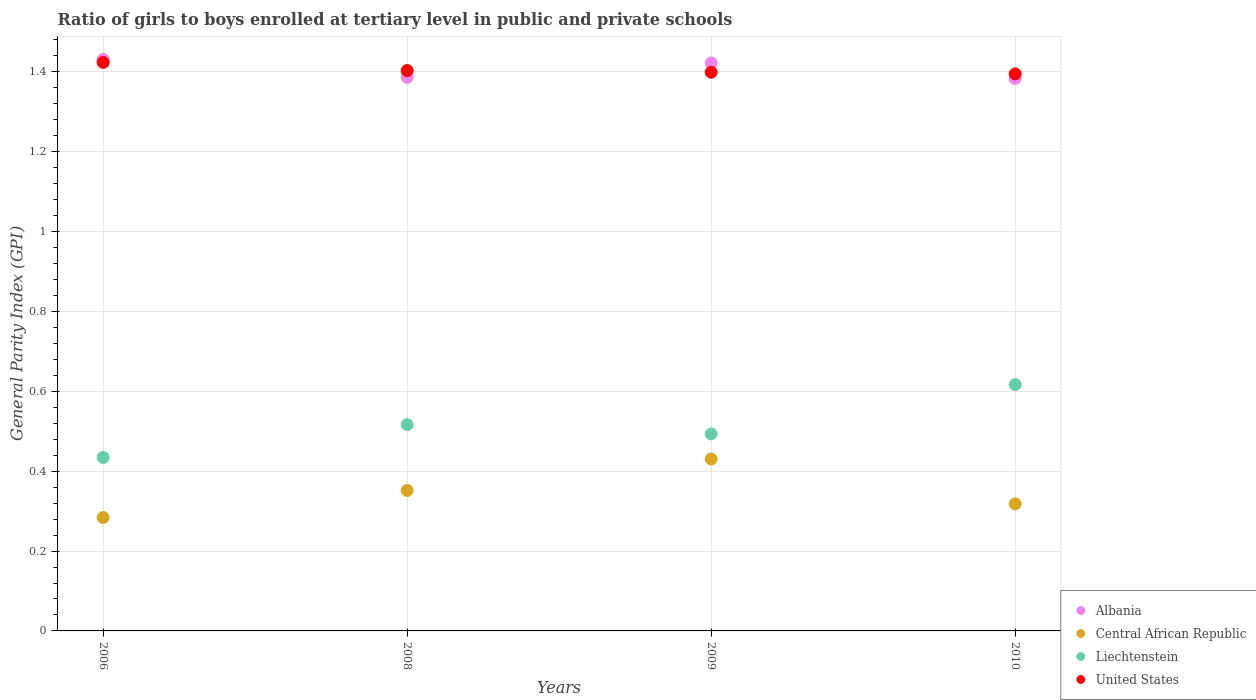What is the general parity index in United States in 2010?
Keep it short and to the point. 1.39. Across all years, what is the maximum general parity index in Liechtenstein?
Provide a succinct answer. 0.62. Across all years, what is the minimum general parity index in United States?
Give a very brief answer. 1.39. In which year was the general parity index in Albania maximum?
Keep it short and to the point. 2006. In which year was the general parity index in United States minimum?
Your answer should be very brief. 2010. What is the total general parity index in United States in the graph?
Offer a very short reply. 5.62. What is the difference between the general parity index in Albania in 2006 and that in 2008?
Your response must be concise. 0.04. What is the difference between the general parity index in Albania in 2008 and the general parity index in United States in 2010?
Give a very brief answer. -0.01. What is the average general parity index in Central African Republic per year?
Provide a succinct answer. 0.35. In the year 2008, what is the difference between the general parity index in Liechtenstein and general parity index in Albania?
Keep it short and to the point. -0.87. What is the ratio of the general parity index in Central African Republic in 2008 to that in 2010?
Offer a very short reply. 1.11. What is the difference between the highest and the second highest general parity index in Central African Republic?
Your answer should be very brief. 0.08. What is the difference between the highest and the lowest general parity index in Central African Republic?
Provide a succinct answer. 0.15. Is the sum of the general parity index in United States in 2006 and 2009 greater than the maximum general parity index in Liechtenstein across all years?
Make the answer very short. Yes. Is it the case that in every year, the sum of the general parity index in United States and general parity index in Central African Republic  is greater than the sum of general parity index in Liechtenstein and general parity index in Albania?
Your response must be concise. No. Are the values on the major ticks of Y-axis written in scientific E-notation?
Provide a succinct answer. No. Where does the legend appear in the graph?
Provide a short and direct response. Bottom right. How many legend labels are there?
Your answer should be very brief. 4. How are the legend labels stacked?
Your answer should be compact. Vertical. What is the title of the graph?
Keep it short and to the point. Ratio of girls to boys enrolled at tertiary level in public and private schools. What is the label or title of the X-axis?
Ensure brevity in your answer.  Years. What is the label or title of the Y-axis?
Your response must be concise. General Parity Index (GPI). What is the General Parity Index (GPI) of Albania in 2006?
Your answer should be compact. 1.43. What is the General Parity Index (GPI) in Central African Republic in 2006?
Your response must be concise. 0.28. What is the General Parity Index (GPI) of Liechtenstein in 2006?
Ensure brevity in your answer.  0.43. What is the General Parity Index (GPI) in United States in 2006?
Ensure brevity in your answer.  1.42. What is the General Parity Index (GPI) in Albania in 2008?
Offer a very short reply. 1.39. What is the General Parity Index (GPI) in Central African Republic in 2008?
Your answer should be compact. 0.35. What is the General Parity Index (GPI) of Liechtenstein in 2008?
Your response must be concise. 0.52. What is the General Parity Index (GPI) in United States in 2008?
Your response must be concise. 1.4. What is the General Parity Index (GPI) in Albania in 2009?
Your response must be concise. 1.42. What is the General Parity Index (GPI) in Central African Republic in 2009?
Offer a terse response. 0.43. What is the General Parity Index (GPI) of Liechtenstein in 2009?
Ensure brevity in your answer.  0.49. What is the General Parity Index (GPI) of United States in 2009?
Your answer should be very brief. 1.4. What is the General Parity Index (GPI) in Albania in 2010?
Ensure brevity in your answer.  1.38. What is the General Parity Index (GPI) of Central African Republic in 2010?
Give a very brief answer. 0.32. What is the General Parity Index (GPI) in Liechtenstein in 2010?
Give a very brief answer. 0.62. What is the General Parity Index (GPI) of United States in 2010?
Give a very brief answer. 1.39. Across all years, what is the maximum General Parity Index (GPI) of Albania?
Ensure brevity in your answer.  1.43. Across all years, what is the maximum General Parity Index (GPI) of Central African Republic?
Make the answer very short. 0.43. Across all years, what is the maximum General Parity Index (GPI) of Liechtenstein?
Make the answer very short. 0.62. Across all years, what is the maximum General Parity Index (GPI) of United States?
Offer a terse response. 1.42. Across all years, what is the minimum General Parity Index (GPI) of Albania?
Give a very brief answer. 1.38. Across all years, what is the minimum General Parity Index (GPI) of Central African Republic?
Your answer should be very brief. 0.28. Across all years, what is the minimum General Parity Index (GPI) in Liechtenstein?
Your answer should be very brief. 0.43. Across all years, what is the minimum General Parity Index (GPI) in United States?
Offer a terse response. 1.39. What is the total General Parity Index (GPI) in Albania in the graph?
Your response must be concise. 5.62. What is the total General Parity Index (GPI) in Central African Republic in the graph?
Your response must be concise. 1.38. What is the total General Parity Index (GPI) of Liechtenstein in the graph?
Offer a very short reply. 2.06. What is the total General Parity Index (GPI) in United States in the graph?
Make the answer very short. 5.62. What is the difference between the General Parity Index (GPI) in Albania in 2006 and that in 2008?
Ensure brevity in your answer.  0.04. What is the difference between the General Parity Index (GPI) in Central African Republic in 2006 and that in 2008?
Provide a succinct answer. -0.07. What is the difference between the General Parity Index (GPI) of Liechtenstein in 2006 and that in 2008?
Make the answer very short. -0.08. What is the difference between the General Parity Index (GPI) in United States in 2006 and that in 2008?
Provide a succinct answer. 0.02. What is the difference between the General Parity Index (GPI) of Albania in 2006 and that in 2009?
Make the answer very short. 0.01. What is the difference between the General Parity Index (GPI) of Central African Republic in 2006 and that in 2009?
Your answer should be very brief. -0.15. What is the difference between the General Parity Index (GPI) of Liechtenstein in 2006 and that in 2009?
Offer a very short reply. -0.06. What is the difference between the General Parity Index (GPI) of United States in 2006 and that in 2009?
Your answer should be very brief. 0.02. What is the difference between the General Parity Index (GPI) in Albania in 2006 and that in 2010?
Your answer should be compact. 0.05. What is the difference between the General Parity Index (GPI) in Central African Republic in 2006 and that in 2010?
Your answer should be very brief. -0.03. What is the difference between the General Parity Index (GPI) in Liechtenstein in 2006 and that in 2010?
Provide a short and direct response. -0.18. What is the difference between the General Parity Index (GPI) of United States in 2006 and that in 2010?
Offer a very short reply. 0.03. What is the difference between the General Parity Index (GPI) in Albania in 2008 and that in 2009?
Provide a short and direct response. -0.04. What is the difference between the General Parity Index (GPI) of Central African Republic in 2008 and that in 2009?
Offer a terse response. -0.08. What is the difference between the General Parity Index (GPI) in Liechtenstein in 2008 and that in 2009?
Your answer should be compact. 0.02. What is the difference between the General Parity Index (GPI) in United States in 2008 and that in 2009?
Give a very brief answer. 0. What is the difference between the General Parity Index (GPI) in Albania in 2008 and that in 2010?
Your answer should be compact. 0. What is the difference between the General Parity Index (GPI) of Central African Republic in 2008 and that in 2010?
Offer a terse response. 0.03. What is the difference between the General Parity Index (GPI) of Liechtenstein in 2008 and that in 2010?
Provide a succinct answer. -0.1. What is the difference between the General Parity Index (GPI) of United States in 2008 and that in 2010?
Your answer should be very brief. 0.01. What is the difference between the General Parity Index (GPI) in Albania in 2009 and that in 2010?
Keep it short and to the point. 0.04. What is the difference between the General Parity Index (GPI) of Central African Republic in 2009 and that in 2010?
Offer a very short reply. 0.11. What is the difference between the General Parity Index (GPI) of Liechtenstein in 2009 and that in 2010?
Provide a short and direct response. -0.12. What is the difference between the General Parity Index (GPI) in United States in 2009 and that in 2010?
Provide a short and direct response. 0. What is the difference between the General Parity Index (GPI) in Albania in 2006 and the General Parity Index (GPI) in Central African Republic in 2008?
Your answer should be compact. 1.08. What is the difference between the General Parity Index (GPI) in Albania in 2006 and the General Parity Index (GPI) in Liechtenstein in 2008?
Offer a very short reply. 0.91. What is the difference between the General Parity Index (GPI) of Albania in 2006 and the General Parity Index (GPI) of United States in 2008?
Your response must be concise. 0.03. What is the difference between the General Parity Index (GPI) in Central African Republic in 2006 and the General Parity Index (GPI) in Liechtenstein in 2008?
Provide a short and direct response. -0.23. What is the difference between the General Parity Index (GPI) of Central African Republic in 2006 and the General Parity Index (GPI) of United States in 2008?
Your answer should be very brief. -1.12. What is the difference between the General Parity Index (GPI) of Liechtenstein in 2006 and the General Parity Index (GPI) of United States in 2008?
Offer a very short reply. -0.97. What is the difference between the General Parity Index (GPI) of Albania in 2006 and the General Parity Index (GPI) of Liechtenstein in 2009?
Offer a terse response. 0.94. What is the difference between the General Parity Index (GPI) in Albania in 2006 and the General Parity Index (GPI) in United States in 2009?
Keep it short and to the point. 0.03. What is the difference between the General Parity Index (GPI) in Central African Republic in 2006 and the General Parity Index (GPI) in Liechtenstein in 2009?
Your answer should be compact. -0.21. What is the difference between the General Parity Index (GPI) of Central African Republic in 2006 and the General Parity Index (GPI) of United States in 2009?
Make the answer very short. -1.12. What is the difference between the General Parity Index (GPI) in Liechtenstein in 2006 and the General Parity Index (GPI) in United States in 2009?
Provide a short and direct response. -0.96. What is the difference between the General Parity Index (GPI) of Albania in 2006 and the General Parity Index (GPI) of Central African Republic in 2010?
Your response must be concise. 1.11. What is the difference between the General Parity Index (GPI) in Albania in 2006 and the General Parity Index (GPI) in Liechtenstein in 2010?
Offer a very short reply. 0.81. What is the difference between the General Parity Index (GPI) of Albania in 2006 and the General Parity Index (GPI) of United States in 2010?
Ensure brevity in your answer.  0.04. What is the difference between the General Parity Index (GPI) of Central African Republic in 2006 and the General Parity Index (GPI) of Liechtenstein in 2010?
Provide a succinct answer. -0.33. What is the difference between the General Parity Index (GPI) in Central African Republic in 2006 and the General Parity Index (GPI) in United States in 2010?
Make the answer very short. -1.11. What is the difference between the General Parity Index (GPI) of Liechtenstein in 2006 and the General Parity Index (GPI) of United States in 2010?
Provide a short and direct response. -0.96. What is the difference between the General Parity Index (GPI) in Albania in 2008 and the General Parity Index (GPI) in Central African Republic in 2009?
Keep it short and to the point. 0.96. What is the difference between the General Parity Index (GPI) of Albania in 2008 and the General Parity Index (GPI) of Liechtenstein in 2009?
Keep it short and to the point. 0.89. What is the difference between the General Parity Index (GPI) in Albania in 2008 and the General Parity Index (GPI) in United States in 2009?
Your response must be concise. -0.01. What is the difference between the General Parity Index (GPI) of Central African Republic in 2008 and the General Parity Index (GPI) of Liechtenstein in 2009?
Give a very brief answer. -0.14. What is the difference between the General Parity Index (GPI) of Central African Republic in 2008 and the General Parity Index (GPI) of United States in 2009?
Your response must be concise. -1.05. What is the difference between the General Parity Index (GPI) in Liechtenstein in 2008 and the General Parity Index (GPI) in United States in 2009?
Ensure brevity in your answer.  -0.88. What is the difference between the General Parity Index (GPI) in Albania in 2008 and the General Parity Index (GPI) in Central African Republic in 2010?
Your response must be concise. 1.07. What is the difference between the General Parity Index (GPI) of Albania in 2008 and the General Parity Index (GPI) of Liechtenstein in 2010?
Your answer should be compact. 0.77. What is the difference between the General Parity Index (GPI) of Albania in 2008 and the General Parity Index (GPI) of United States in 2010?
Your response must be concise. -0.01. What is the difference between the General Parity Index (GPI) in Central African Republic in 2008 and the General Parity Index (GPI) in Liechtenstein in 2010?
Provide a succinct answer. -0.27. What is the difference between the General Parity Index (GPI) in Central African Republic in 2008 and the General Parity Index (GPI) in United States in 2010?
Give a very brief answer. -1.04. What is the difference between the General Parity Index (GPI) in Liechtenstein in 2008 and the General Parity Index (GPI) in United States in 2010?
Give a very brief answer. -0.88. What is the difference between the General Parity Index (GPI) of Albania in 2009 and the General Parity Index (GPI) of Central African Republic in 2010?
Offer a terse response. 1.1. What is the difference between the General Parity Index (GPI) of Albania in 2009 and the General Parity Index (GPI) of Liechtenstein in 2010?
Offer a very short reply. 0.81. What is the difference between the General Parity Index (GPI) of Albania in 2009 and the General Parity Index (GPI) of United States in 2010?
Keep it short and to the point. 0.03. What is the difference between the General Parity Index (GPI) of Central African Republic in 2009 and the General Parity Index (GPI) of Liechtenstein in 2010?
Your answer should be compact. -0.19. What is the difference between the General Parity Index (GPI) of Central African Republic in 2009 and the General Parity Index (GPI) of United States in 2010?
Ensure brevity in your answer.  -0.96. What is the difference between the General Parity Index (GPI) in Liechtenstein in 2009 and the General Parity Index (GPI) in United States in 2010?
Provide a succinct answer. -0.9. What is the average General Parity Index (GPI) in Albania per year?
Provide a short and direct response. 1.41. What is the average General Parity Index (GPI) of Central African Republic per year?
Ensure brevity in your answer.  0.35. What is the average General Parity Index (GPI) in Liechtenstein per year?
Provide a succinct answer. 0.52. What is the average General Parity Index (GPI) in United States per year?
Offer a terse response. 1.41. In the year 2006, what is the difference between the General Parity Index (GPI) of Albania and General Parity Index (GPI) of Central African Republic?
Your answer should be very brief. 1.15. In the year 2006, what is the difference between the General Parity Index (GPI) of Albania and General Parity Index (GPI) of United States?
Offer a very short reply. 0.01. In the year 2006, what is the difference between the General Parity Index (GPI) in Central African Republic and General Parity Index (GPI) in Liechtenstein?
Ensure brevity in your answer.  -0.15. In the year 2006, what is the difference between the General Parity Index (GPI) of Central African Republic and General Parity Index (GPI) of United States?
Your answer should be very brief. -1.14. In the year 2006, what is the difference between the General Parity Index (GPI) in Liechtenstein and General Parity Index (GPI) in United States?
Ensure brevity in your answer.  -0.99. In the year 2008, what is the difference between the General Parity Index (GPI) in Albania and General Parity Index (GPI) in Central African Republic?
Offer a very short reply. 1.03. In the year 2008, what is the difference between the General Parity Index (GPI) of Albania and General Parity Index (GPI) of Liechtenstein?
Your answer should be compact. 0.87. In the year 2008, what is the difference between the General Parity Index (GPI) in Albania and General Parity Index (GPI) in United States?
Ensure brevity in your answer.  -0.02. In the year 2008, what is the difference between the General Parity Index (GPI) of Central African Republic and General Parity Index (GPI) of Liechtenstein?
Your response must be concise. -0.17. In the year 2008, what is the difference between the General Parity Index (GPI) of Central African Republic and General Parity Index (GPI) of United States?
Make the answer very short. -1.05. In the year 2008, what is the difference between the General Parity Index (GPI) of Liechtenstein and General Parity Index (GPI) of United States?
Ensure brevity in your answer.  -0.89. In the year 2009, what is the difference between the General Parity Index (GPI) in Albania and General Parity Index (GPI) in Central African Republic?
Keep it short and to the point. 0.99. In the year 2009, what is the difference between the General Parity Index (GPI) in Albania and General Parity Index (GPI) in Liechtenstein?
Offer a terse response. 0.93. In the year 2009, what is the difference between the General Parity Index (GPI) of Albania and General Parity Index (GPI) of United States?
Your answer should be very brief. 0.02. In the year 2009, what is the difference between the General Parity Index (GPI) of Central African Republic and General Parity Index (GPI) of Liechtenstein?
Give a very brief answer. -0.06. In the year 2009, what is the difference between the General Parity Index (GPI) in Central African Republic and General Parity Index (GPI) in United States?
Provide a succinct answer. -0.97. In the year 2009, what is the difference between the General Parity Index (GPI) of Liechtenstein and General Parity Index (GPI) of United States?
Make the answer very short. -0.91. In the year 2010, what is the difference between the General Parity Index (GPI) in Albania and General Parity Index (GPI) in Central African Republic?
Give a very brief answer. 1.07. In the year 2010, what is the difference between the General Parity Index (GPI) of Albania and General Parity Index (GPI) of Liechtenstein?
Provide a succinct answer. 0.77. In the year 2010, what is the difference between the General Parity Index (GPI) of Albania and General Parity Index (GPI) of United States?
Make the answer very short. -0.01. In the year 2010, what is the difference between the General Parity Index (GPI) of Central African Republic and General Parity Index (GPI) of Liechtenstein?
Keep it short and to the point. -0.3. In the year 2010, what is the difference between the General Parity Index (GPI) of Central African Republic and General Parity Index (GPI) of United States?
Keep it short and to the point. -1.08. In the year 2010, what is the difference between the General Parity Index (GPI) in Liechtenstein and General Parity Index (GPI) in United States?
Your answer should be compact. -0.78. What is the ratio of the General Parity Index (GPI) of Albania in 2006 to that in 2008?
Your answer should be compact. 1.03. What is the ratio of the General Parity Index (GPI) in Central African Republic in 2006 to that in 2008?
Offer a terse response. 0.81. What is the ratio of the General Parity Index (GPI) in Liechtenstein in 2006 to that in 2008?
Give a very brief answer. 0.84. What is the ratio of the General Parity Index (GPI) of United States in 2006 to that in 2008?
Provide a succinct answer. 1.01. What is the ratio of the General Parity Index (GPI) of Albania in 2006 to that in 2009?
Keep it short and to the point. 1.01. What is the ratio of the General Parity Index (GPI) in Central African Republic in 2006 to that in 2009?
Offer a very short reply. 0.66. What is the ratio of the General Parity Index (GPI) of Liechtenstein in 2006 to that in 2009?
Offer a very short reply. 0.88. What is the ratio of the General Parity Index (GPI) in United States in 2006 to that in 2009?
Your answer should be compact. 1.02. What is the ratio of the General Parity Index (GPI) in Albania in 2006 to that in 2010?
Give a very brief answer. 1.03. What is the ratio of the General Parity Index (GPI) of Central African Republic in 2006 to that in 2010?
Your response must be concise. 0.89. What is the ratio of the General Parity Index (GPI) in Liechtenstein in 2006 to that in 2010?
Provide a succinct answer. 0.7. What is the ratio of the General Parity Index (GPI) in United States in 2006 to that in 2010?
Make the answer very short. 1.02. What is the ratio of the General Parity Index (GPI) in Albania in 2008 to that in 2009?
Provide a short and direct response. 0.97. What is the ratio of the General Parity Index (GPI) of Central African Republic in 2008 to that in 2009?
Provide a succinct answer. 0.82. What is the ratio of the General Parity Index (GPI) in Liechtenstein in 2008 to that in 2009?
Your answer should be compact. 1.05. What is the ratio of the General Parity Index (GPI) in United States in 2008 to that in 2009?
Offer a very short reply. 1. What is the ratio of the General Parity Index (GPI) in Central African Republic in 2008 to that in 2010?
Provide a short and direct response. 1.11. What is the ratio of the General Parity Index (GPI) of Liechtenstein in 2008 to that in 2010?
Make the answer very short. 0.84. What is the ratio of the General Parity Index (GPI) of Albania in 2009 to that in 2010?
Your response must be concise. 1.03. What is the ratio of the General Parity Index (GPI) of Central African Republic in 2009 to that in 2010?
Provide a succinct answer. 1.35. What is the ratio of the General Parity Index (GPI) of Liechtenstein in 2009 to that in 2010?
Provide a succinct answer. 0.8. What is the difference between the highest and the second highest General Parity Index (GPI) of Albania?
Your answer should be very brief. 0.01. What is the difference between the highest and the second highest General Parity Index (GPI) of Central African Republic?
Offer a terse response. 0.08. What is the difference between the highest and the second highest General Parity Index (GPI) in Liechtenstein?
Provide a succinct answer. 0.1. What is the difference between the highest and the second highest General Parity Index (GPI) of United States?
Keep it short and to the point. 0.02. What is the difference between the highest and the lowest General Parity Index (GPI) of Albania?
Offer a terse response. 0.05. What is the difference between the highest and the lowest General Parity Index (GPI) of Central African Republic?
Keep it short and to the point. 0.15. What is the difference between the highest and the lowest General Parity Index (GPI) in Liechtenstein?
Offer a very short reply. 0.18. What is the difference between the highest and the lowest General Parity Index (GPI) in United States?
Provide a succinct answer. 0.03. 